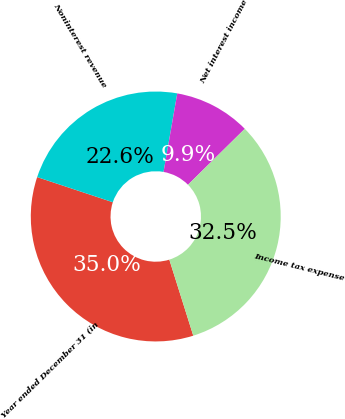<chart> <loc_0><loc_0><loc_500><loc_500><pie_chart><fcel>Year ended December 31 (in<fcel>Noninterest revenue<fcel>Net interest income<fcel>Income tax expense<nl><fcel>34.96%<fcel>22.65%<fcel>9.87%<fcel>32.52%<nl></chart> 